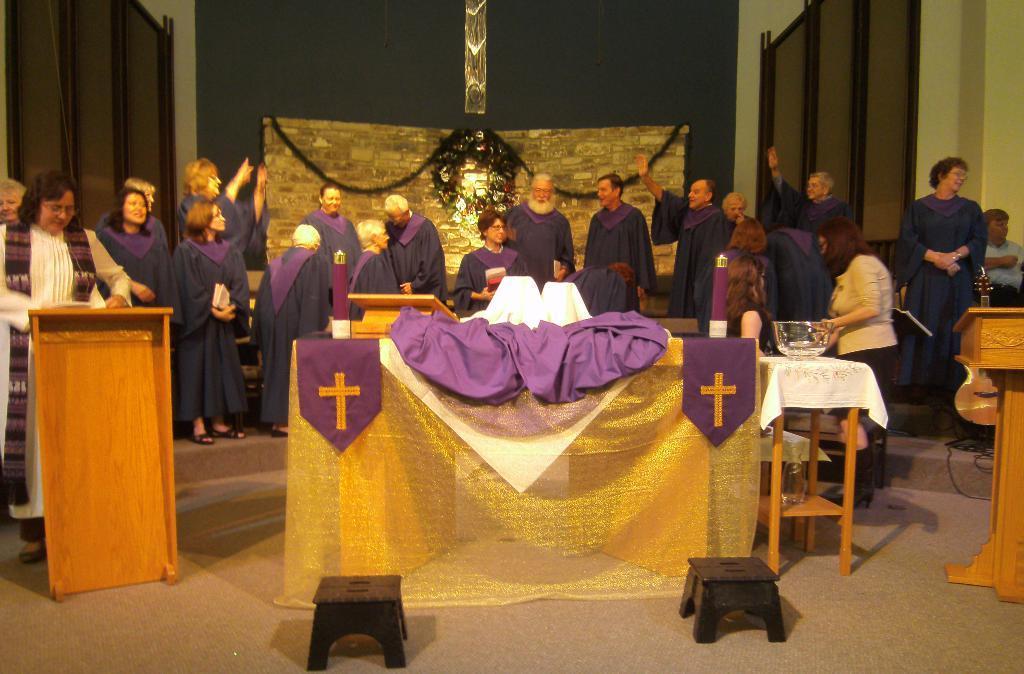Describe this image in one or two sentences. There is a group of people standing here. There is a podium in front of which a woman is standing. All of them are wearing a similar dress. There are some stools here. In the background we can observe a wall here. 